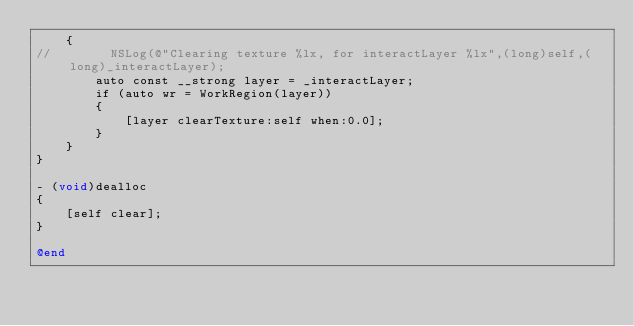Convert code to text. <code><loc_0><loc_0><loc_500><loc_500><_ObjectiveC_>    {
//        NSLog(@"Clearing texture %lx, for interactLayer %lx",(long)self,(long)_interactLayer);
        auto const __strong layer = _interactLayer;
        if (auto wr = WorkRegion(layer))
        {
            [layer clearTexture:self when:0.0];
        }
    }
}

- (void)dealloc
{
    [self clear];
}

@end
</code> 